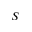<formula> <loc_0><loc_0><loc_500><loc_500>S</formula> 